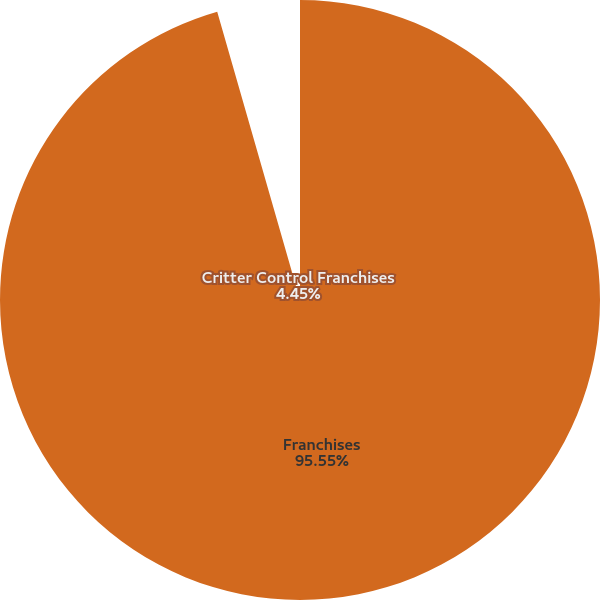Convert chart to OTSL. <chart><loc_0><loc_0><loc_500><loc_500><pie_chart><fcel>Franchises<fcel>Critter Control Franchises<nl><fcel>95.55%<fcel>4.45%<nl></chart> 